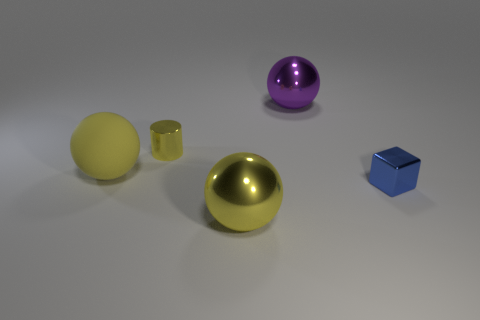What material is the purple object that is the same shape as the large yellow metallic thing?
Make the answer very short. Metal. Are there any red things that have the same size as the purple metal object?
Your response must be concise. No. Does the yellow object in front of the rubber thing have the same shape as the small blue metallic object?
Ensure brevity in your answer.  No. What color is the cylinder?
Your answer should be compact. Yellow. The shiny object that is the same color as the tiny cylinder is what shape?
Your response must be concise. Sphere. Is there a purple sphere?
Your answer should be very brief. Yes. What is the size of the other sphere that is made of the same material as the big purple sphere?
Provide a succinct answer. Large. The thing that is to the right of the large metal sphere behind the thing that is to the right of the large purple object is what shape?
Your response must be concise. Cube. Are there the same number of metallic cubes that are behind the purple metal ball and blue metallic cubes?
Ensure brevity in your answer.  No. There is a metal ball that is the same color as the matte sphere; what is its size?
Your response must be concise. Large. 